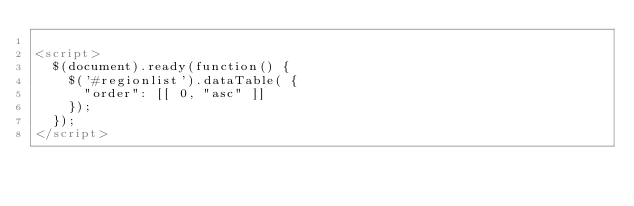Convert code to text. <code><loc_0><loc_0><loc_500><loc_500><_HTML_>
<script>
  $(document).ready(function() {
    $('#regionlist').dataTable( {
      "order": [[ 0, "asc" ]]
    });
  });
</script>

</code> 